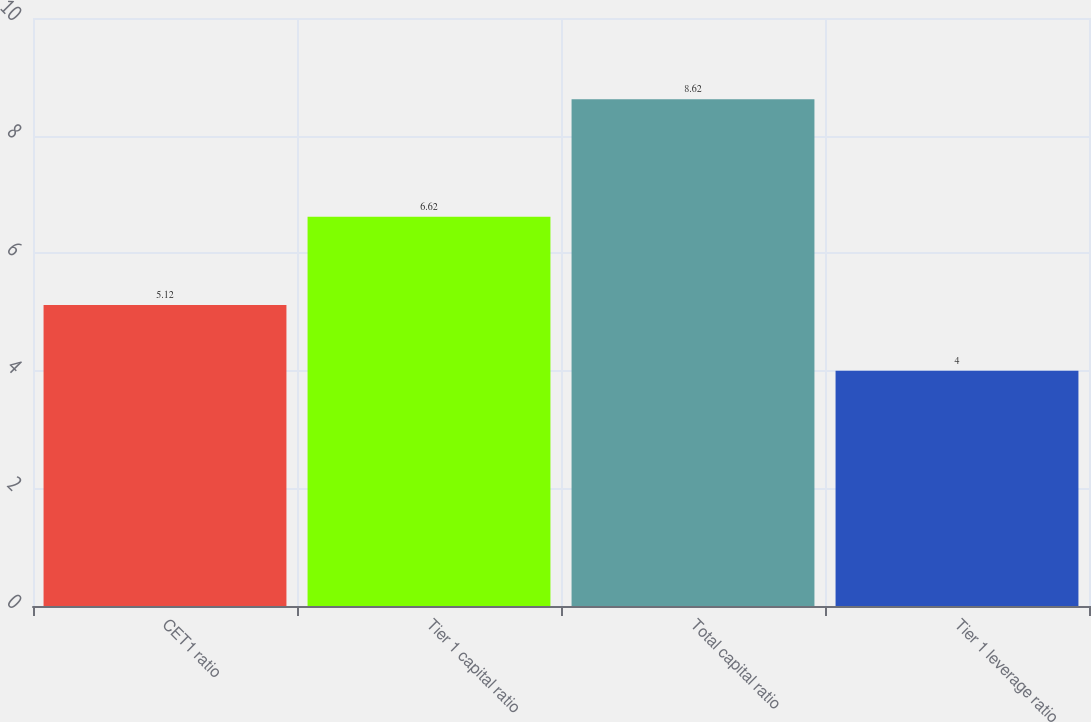Convert chart to OTSL. <chart><loc_0><loc_0><loc_500><loc_500><bar_chart><fcel>CET1 ratio<fcel>Tier 1 capital ratio<fcel>Total capital ratio<fcel>Tier 1 leverage ratio<nl><fcel>5.12<fcel>6.62<fcel>8.62<fcel>4<nl></chart> 